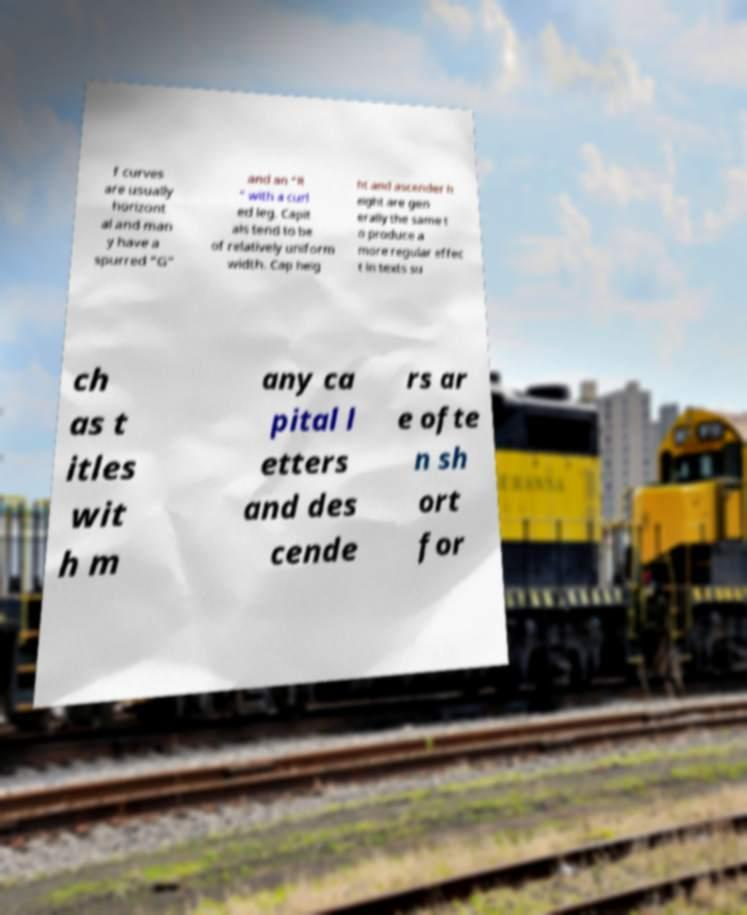Could you extract and type out the text from this image? f curves are usually horizont al and man y have a spurred "G" and an "R " with a curl ed leg. Capit als tend to be of relatively uniform width. Cap heig ht and ascender h eight are gen erally the same t o produce a more regular effec t in texts su ch as t itles wit h m any ca pital l etters and des cende rs ar e ofte n sh ort for 